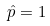<formula> <loc_0><loc_0><loc_500><loc_500>\hat { p } = 1</formula> 